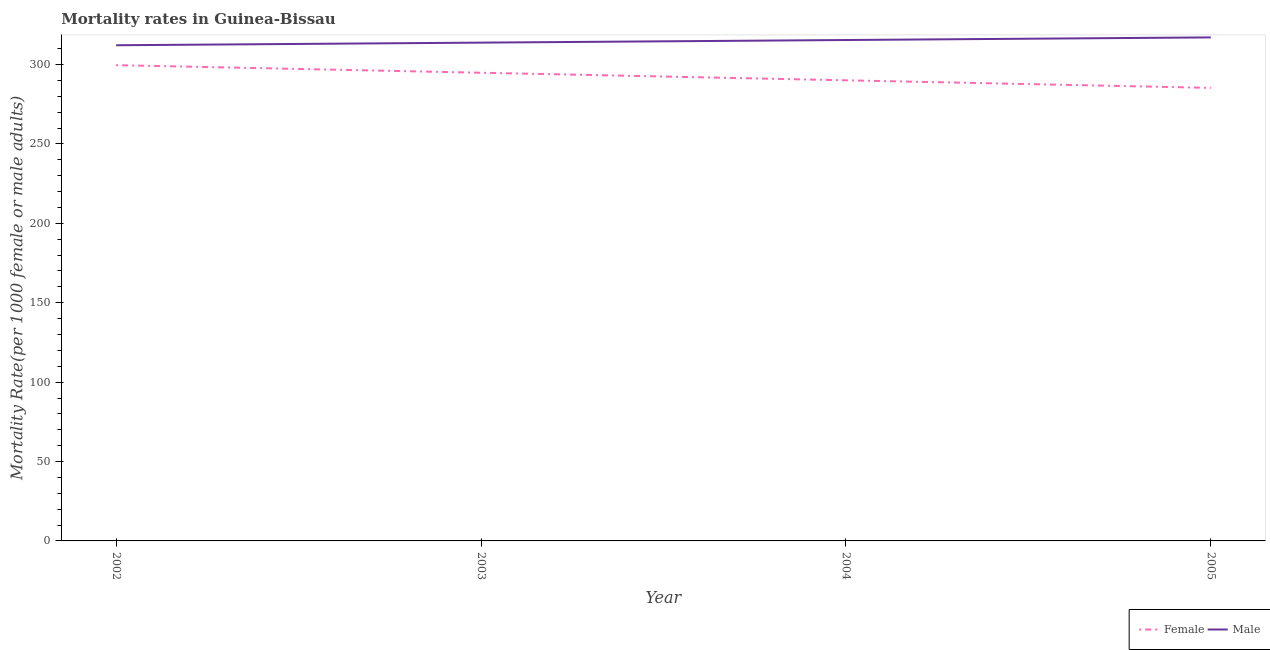Does the line corresponding to female mortality rate intersect with the line corresponding to male mortality rate?
Ensure brevity in your answer.  No. Is the number of lines equal to the number of legend labels?
Ensure brevity in your answer.  Yes. What is the male mortality rate in 2005?
Ensure brevity in your answer.  317.08. Across all years, what is the maximum female mortality rate?
Provide a short and direct response. 299.6. Across all years, what is the minimum female mortality rate?
Your answer should be very brief. 285.29. In which year was the male mortality rate minimum?
Give a very brief answer. 2002. What is the total female mortality rate in the graph?
Keep it short and to the point. 1169.78. What is the difference between the male mortality rate in 2002 and that in 2005?
Ensure brevity in your answer.  -4.94. What is the difference between the female mortality rate in 2003 and the male mortality rate in 2004?
Keep it short and to the point. -20.61. What is the average female mortality rate per year?
Make the answer very short. 292.44. In the year 2002, what is the difference between the female mortality rate and male mortality rate?
Offer a terse response. -12.54. What is the ratio of the male mortality rate in 2003 to that in 2005?
Offer a terse response. 0.99. Is the female mortality rate in 2002 less than that in 2004?
Your response must be concise. No. Is the difference between the female mortality rate in 2002 and 2004 greater than the difference between the male mortality rate in 2002 and 2004?
Provide a short and direct response. Yes. What is the difference between the highest and the second highest female mortality rate?
Your answer should be compact. 4.77. What is the difference between the highest and the lowest female mortality rate?
Your response must be concise. 14.3. In how many years, is the male mortality rate greater than the average male mortality rate taken over all years?
Offer a terse response. 2. Is the sum of the male mortality rate in 2003 and 2004 greater than the maximum female mortality rate across all years?
Provide a short and direct response. Yes. Does the female mortality rate monotonically increase over the years?
Provide a short and direct response. No. Is the female mortality rate strictly greater than the male mortality rate over the years?
Your response must be concise. No. How many lines are there?
Make the answer very short. 2. How many years are there in the graph?
Your response must be concise. 4. What is the difference between two consecutive major ticks on the Y-axis?
Give a very brief answer. 50. Are the values on the major ticks of Y-axis written in scientific E-notation?
Offer a very short reply. No. Does the graph contain grids?
Ensure brevity in your answer.  No. How many legend labels are there?
Your response must be concise. 2. What is the title of the graph?
Your response must be concise. Mortality rates in Guinea-Bissau. Does "Technicians" appear as one of the legend labels in the graph?
Provide a short and direct response. No. What is the label or title of the Y-axis?
Give a very brief answer. Mortality Rate(per 1000 female or male adults). What is the Mortality Rate(per 1000 female or male adults) of Female in 2002?
Make the answer very short. 299.6. What is the Mortality Rate(per 1000 female or male adults) in Male in 2002?
Ensure brevity in your answer.  312.14. What is the Mortality Rate(per 1000 female or male adults) in Female in 2003?
Keep it short and to the point. 294.83. What is the Mortality Rate(per 1000 female or male adults) of Male in 2003?
Your answer should be compact. 313.79. What is the Mortality Rate(per 1000 female or male adults) of Female in 2004?
Your response must be concise. 290.06. What is the Mortality Rate(per 1000 female or male adults) in Male in 2004?
Provide a succinct answer. 315.43. What is the Mortality Rate(per 1000 female or male adults) in Female in 2005?
Your response must be concise. 285.29. What is the Mortality Rate(per 1000 female or male adults) in Male in 2005?
Ensure brevity in your answer.  317.08. Across all years, what is the maximum Mortality Rate(per 1000 female or male adults) of Female?
Make the answer very short. 299.6. Across all years, what is the maximum Mortality Rate(per 1000 female or male adults) of Male?
Offer a terse response. 317.08. Across all years, what is the minimum Mortality Rate(per 1000 female or male adults) of Female?
Your answer should be very brief. 285.29. Across all years, what is the minimum Mortality Rate(per 1000 female or male adults) in Male?
Provide a short and direct response. 312.14. What is the total Mortality Rate(per 1000 female or male adults) of Female in the graph?
Offer a very short reply. 1169.78. What is the total Mortality Rate(per 1000 female or male adults) of Male in the graph?
Provide a short and direct response. 1258.44. What is the difference between the Mortality Rate(per 1000 female or male adults) in Female in 2002 and that in 2003?
Ensure brevity in your answer.  4.77. What is the difference between the Mortality Rate(per 1000 female or male adults) of Male in 2002 and that in 2003?
Provide a short and direct response. -1.65. What is the difference between the Mortality Rate(per 1000 female or male adults) of Female in 2002 and that in 2004?
Make the answer very short. 9.54. What is the difference between the Mortality Rate(per 1000 female or male adults) in Male in 2002 and that in 2004?
Your response must be concise. -3.29. What is the difference between the Mortality Rate(per 1000 female or male adults) of Female in 2002 and that in 2005?
Keep it short and to the point. 14.3. What is the difference between the Mortality Rate(per 1000 female or male adults) of Male in 2002 and that in 2005?
Keep it short and to the point. -4.94. What is the difference between the Mortality Rate(per 1000 female or male adults) in Female in 2003 and that in 2004?
Make the answer very short. 4.77. What is the difference between the Mortality Rate(per 1000 female or male adults) in Male in 2003 and that in 2004?
Your answer should be compact. -1.65. What is the difference between the Mortality Rate(per 1000 female or male adults) in Female in 2003 and that in 2005?
Your answer should be compact. 9.54. What is the difference between the Mortality Rate(per 1000 female or male adults) of Male in 2003 and that in 2005?
Offer a terse response. -3.29. What is the difference between the Mortality Rate(per 1000 female or male adults) of Female in 2004 and that in 2005?
Give a very brief answer. 4.77. What is the difference between the Mortality Rate(per 1000 female or male adults) of Male in 2004 and that in 2005?
Offer a terse response. -1.65. What is the difference between the Mortality Rate(per 1000 female or male adults) in Female in 2002 and the Mortality Rate(per 1000 female or male adults) in Male in 2003?
Give a very brief answer. -14.19. What is the difference between the Mortality Rate(per 1000 female or male adults) of Female in 2002 and the Mortality Rate(per 1000 female or male adults) of Male in 2004?
Provide a succinct answer. -15.84. What is the difference between the Mortality Rate(per 1000 female or male adults) of Female in 2002 and the Mortality Rate(per 1000 female or male adults) of Male in 2005?
Give a very brief answer. -17.48. What is the difference between the Mortality Rate(per 1000 female or male adults) in Female in 2003 and the Mortality Rate(per 1000 female or male adults) in Male in 2004?
Ensure brevity in your answer.  -20.61. What is the difference between the Mortality Rate(per 1000 female or male adults) in Female in 2003 and the Mortality Rate(per 1000 female or male adults) in Male in 2005?
Offer a terse response. -22.25. What is the difference between the Mortality Rate(per 1000 female or male adults) in Female in 2004 and the Mortality Rate(per 1000 female or male adults) in Male in 2005?
Give a very brief answer. -27.02. What is the average Mortality Rate(per 1000 female or male adults) of Female per year?
Offer a terse response. 292.44. What is the average Mortality Rate(per 1000 female or male adults) in Male per year?
Your answer should be very brief. 314.61. In the year 2002, what is the difference between the Mortality Rate(per 1000 female or male adults) in Female and Mortality Rate(per 1000 female or male adults) in Male?
Offer a very short reply. -12.54. In the year 2003, what is the difference between the Mortality Rate(per 1000 female or male adults) of Female and Mortality Rate(per 1000 female or male adults) of Male?
Your answer should be compact. -18.96. In the year 2004, what is the difference between the Mortality Rate(per 1000 female or male adults) of Female and Mortality Rate(per 1000 female or male adults) of Male?
Give a very brief answer. -25.37. In the year 2005, what is the difference between the Mortality Rate(per 1000 female or male adults) of Female and Mortality Rate(per 1000 female or male adults) of Male?
Your answer should be very brief. -31.79. What is the ratio of the Mortality Rate(per 1000 female or male adults) of Female in 2002 to that in 2003?
Your answer should be compact. 1.02. What is the ratio of the Mortality Rate(per 1000 female or male adults) of Male in 2002 to that in 2003?
Your answer should be very brief. 0.99. What is the ratio of the Mortality Rate(per 1000 female or male adults) of Female in 2002 to that in 2004?
Offer a terse response. 1.03. What is the ratio of the Mortality Rate(per 1000 female or male adults) of Male in 2002 to that in 2004?
Make the answer very short. 0.99. What is the ratio of the Mortality Rate(per 1000 female or male adults) of Female in 2002 to that in 2005?
Provide a short and direct response. 1.05. What is the ratio of the Mortality Rate(per 1000 female or male adults) of Male in 2002 to that in 2005?
Make the answer very short. 0.98. What is the ratio of the Mortality Rate(per 1000 female or male adults) in Female in 2003 to that in 2004?
Your response must be concise. 1.02. What is the ratio of the Mortality Rate(per 1000 female or male adults) of Male in 2003 to that in 2004?
Keep it short and to the point. 0.99. What is the ratio of the Mortality Rate(per 1000 female or male adults) in Female in 2003 to that in 2005?
Offer a very short reply. 1.03. What is the ratio of the Mortality Rate(per 1000 female or male adults) in Male in 2003 to that in 2005?
Keep it short and to the point. 0.99. What is the ratio of the Mortality Rate(per 1000 female or male adults) of Female in 2004 to that in 2005?
Provide a succinct answer. 1.02. What is the difference between the highest and the second highest Mortality Rate(per 1000 female or male adults) in Female?
Ensure brevity in your answer.  4.77. What is the difference between the highest and the second highest Mortality Rate(per 1000 female or male adults) in Male?
Provide a short and direct response. 1.65. What is the difference between the highest and the lowest Mortality Rate(per 1000 female or male adults) in Female?
Keep it short and to the point. 14.3. What is the difference between the highest and the lowest Mortality Rate(per 1000 female or male adults) of Male?
Make the answer very short. 4.94. 